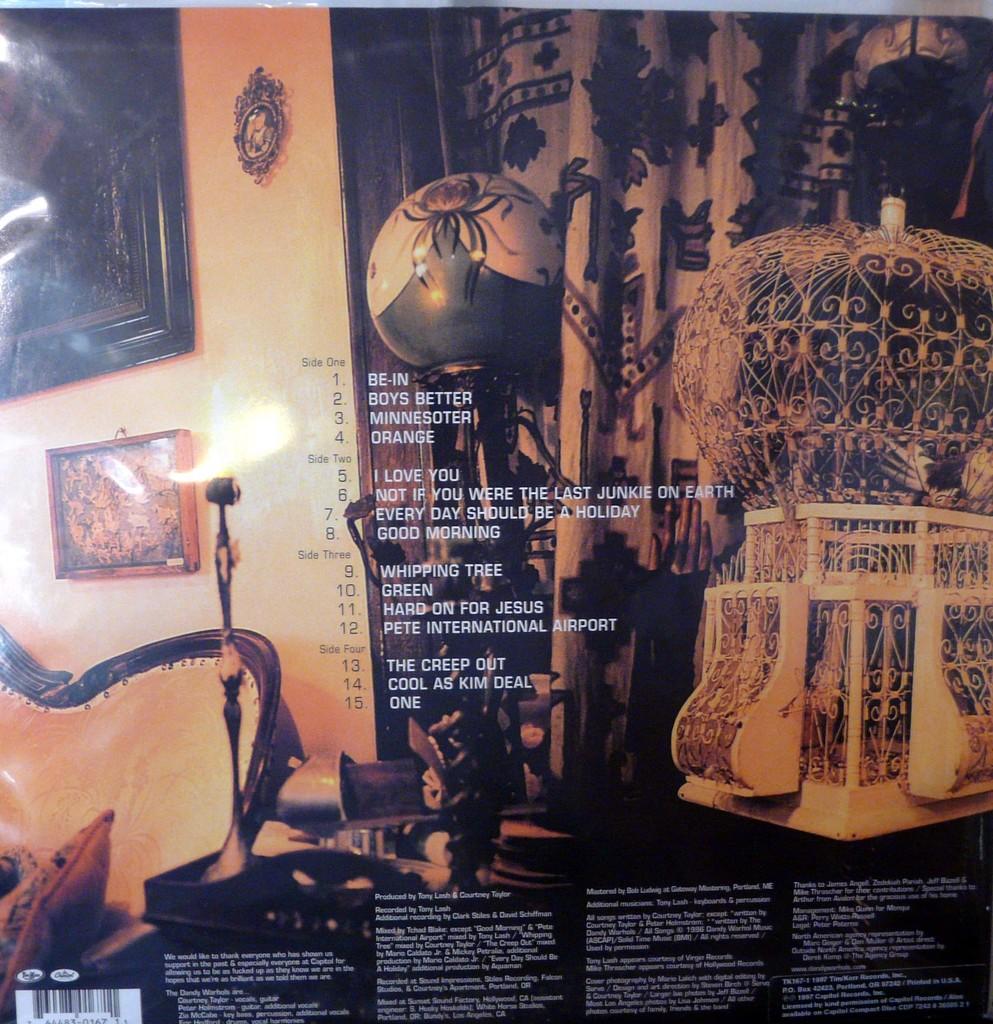What is the first song?
Provide a short and direct response. Be in. What is the title of track 1?
Offer a terse response. Be-in. 